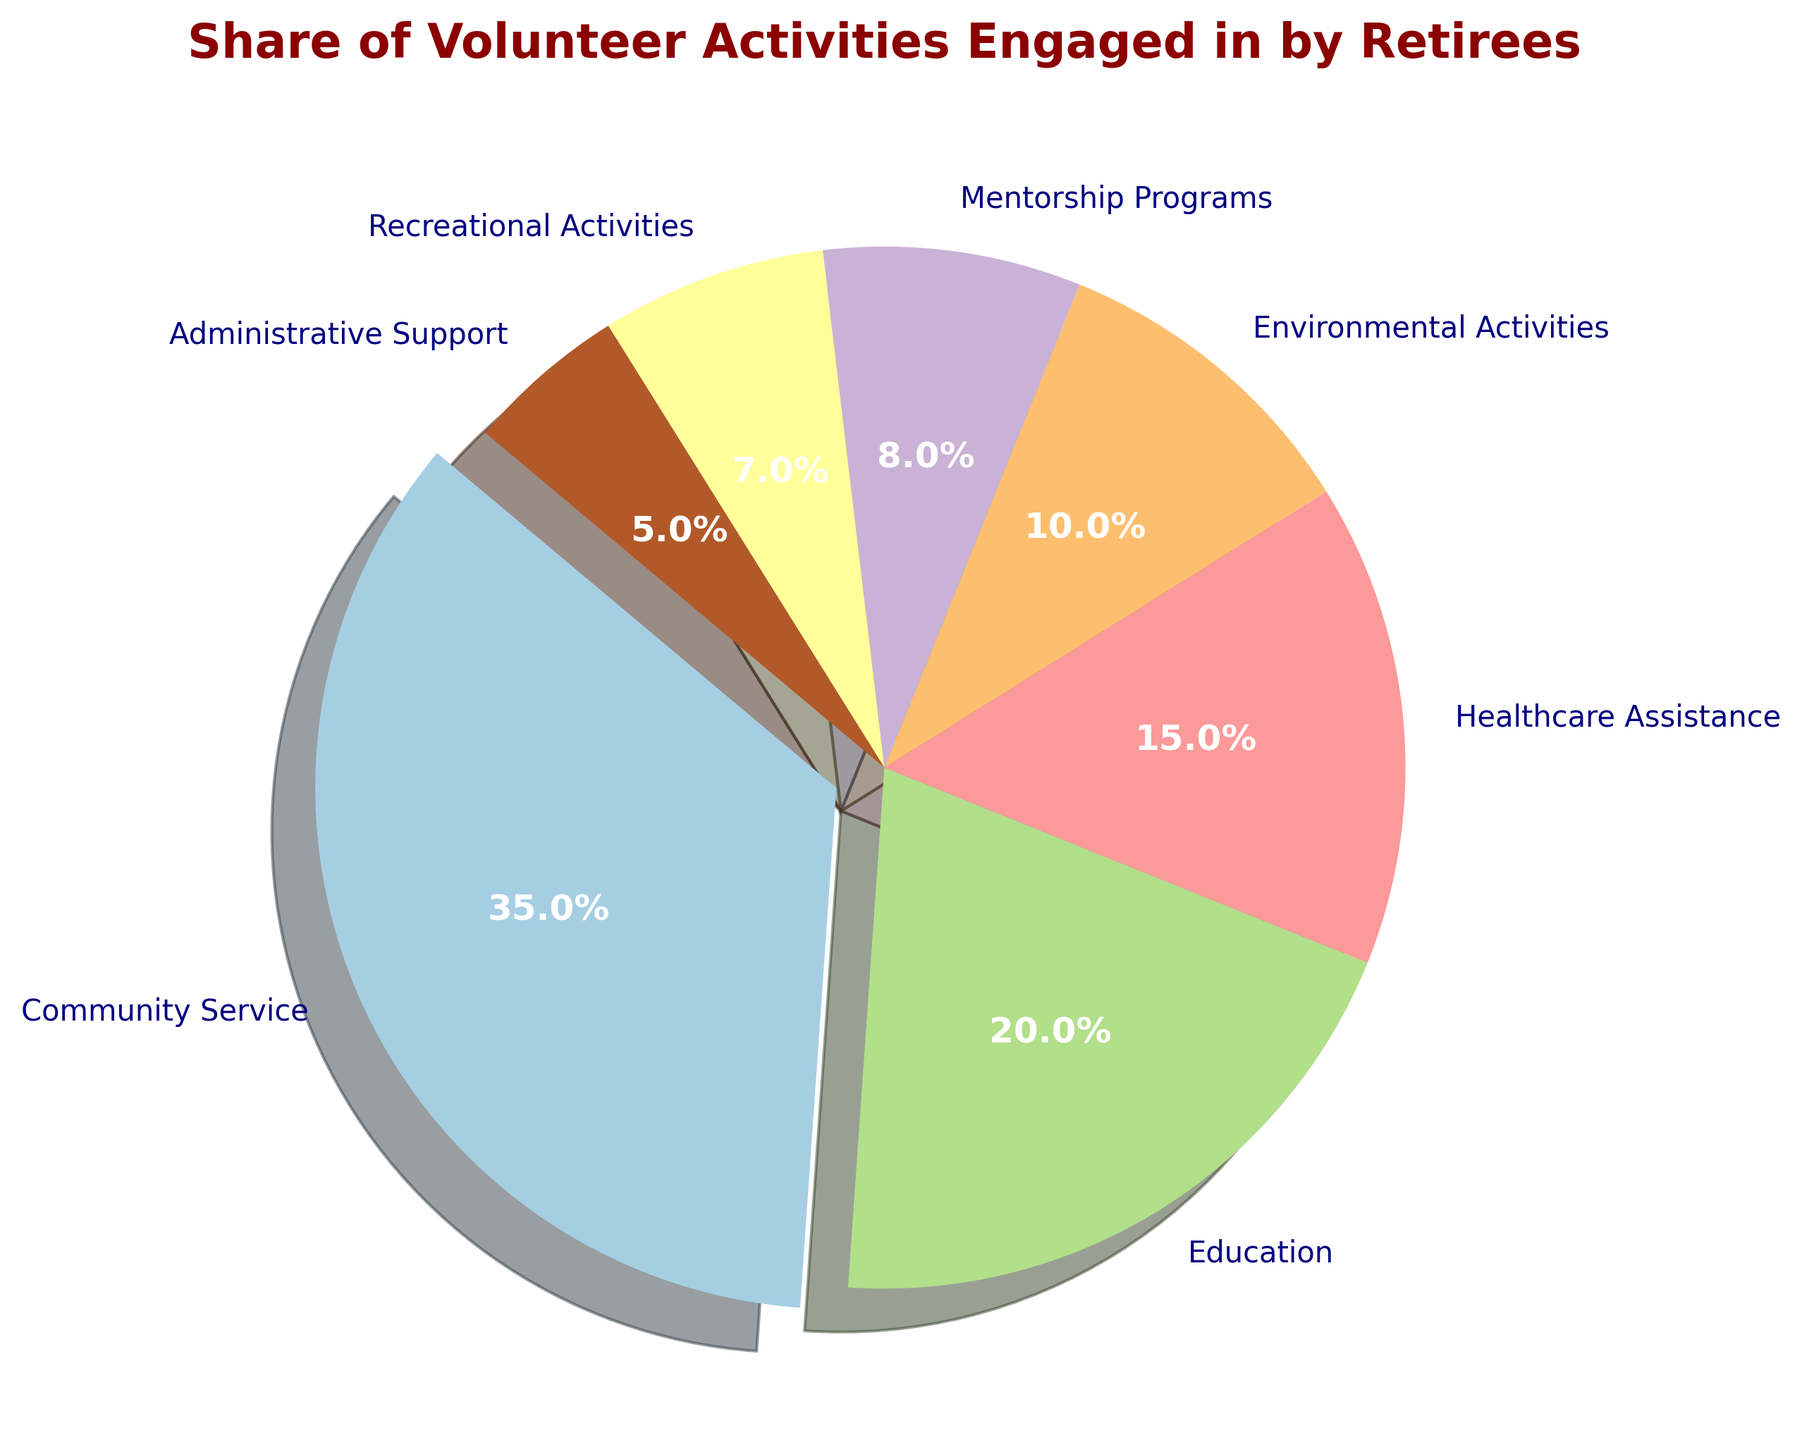What is the category with the largest share of volunteer activities? Observing the pie chart, the slice representing "Community Service" is the largest and slightly exploded.
Answer: Community Service What is the combined percentage share of activities related to healthcare and education? The percentages for "Healthcare Assistance" and "Education" are 15% and 20%, respectively. Adding these together gives 15% + 20% = 35%.
Answer: 35% How much larger is the share of community service activities compared to recreational activities? The percentage for "Community Service" is 35%, and for "Recreational Activities" it is 7%. The difference is 35% - 7% = 28%.
Answer: 28% What are the colors used for "Environmental Activities" and "Mentorship Programs"? "Environmental Activities" and "Mentorship Programs" are represented with different colors in the pie chart. "Environmental Activities" is likely a distinct color like green and "Mentorship Programs" could be another distinct color such as yellow or purple (exact colors seen in pie chart).
Answer: Green and Yellow/Purple Which activities are less than 10% in share and what are their exact percentages? By observing the pie chart, "Mentorship Programs" (8%), "Recreational Activities" (7%), and "Administrative Support" (5%) all have less than 10% share.
Answer: Mentorship Programs: 8%, Recreational Activities: 7%, Administrative Support: 5% Is the share of educational activities greater than that of healthcare assistance? The percentage for "Education" is 20% and for "Healthcare Assistance" it is 15%. Since 20% is greater than 15%, the share of educational activities is indeed greater.
Answer: Yes If the percentage of environmental activities was increased by 5%, what would be the new percentage? The current share for "Environmental Activities" is 10%. Increasing this by 5% would result in 10% + 5% = 15%.
Answer: 15% What is the second most engaged volunteer activity among retirees? The second largest slice in the pie chart represents "Education" with a percentage of 20%.
Answer: Education Which activities together make up exactly half of the total volunteer share? "Community Service" (35%) and "Education" (20%) together make 35% + 20% = 55%. To find a combination that makes 50%, we consider "Community Service" (35%) and "Healthcare Assistance" (15%), which add up to 50%.
Answer: Community Service and Healthcare Assistance Compare the share of administrative support to environmental activities in terms of ratio. The percentage for "Administrative Support" is 5% and for "Environmental Activities" it is 10%. The ratio of Administrative Support to Environmental Activities is 5% : 10%, which simplifies to 1:2.
Answer: 1:2 